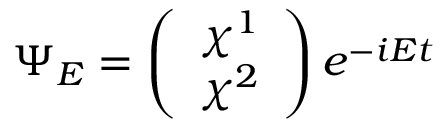<formula> <loc_0><loc_0><loc_500><loc_500>\Psi _ { E } = \left ( \begin{array} { c } { { \chi ^ { 1 } } } \\ { { \chi ^ { 2 } } } \end{array} \right ) e ^ { - i E t }</formula> 